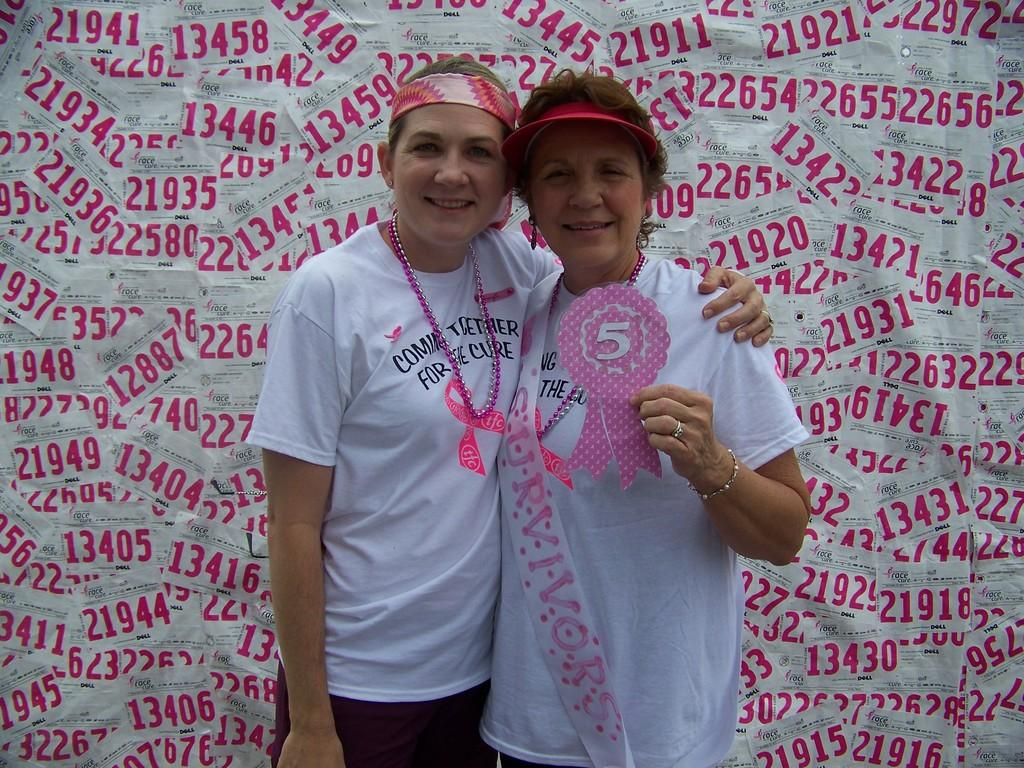How many people are in the image? There are two women in the image. What are the women wearing? The women are wearing white t-shirts. What can be seen in the background of the image? Papers are visible in the background of the image. What additional detail can be observed in the image? There is a tag present in the image. How many men are present in the image? There are no men present in the image; it features two women. What type of angle is being used to take the picture? The angle used to take the picture is not mentioned in the image, so it cannot be determined. 